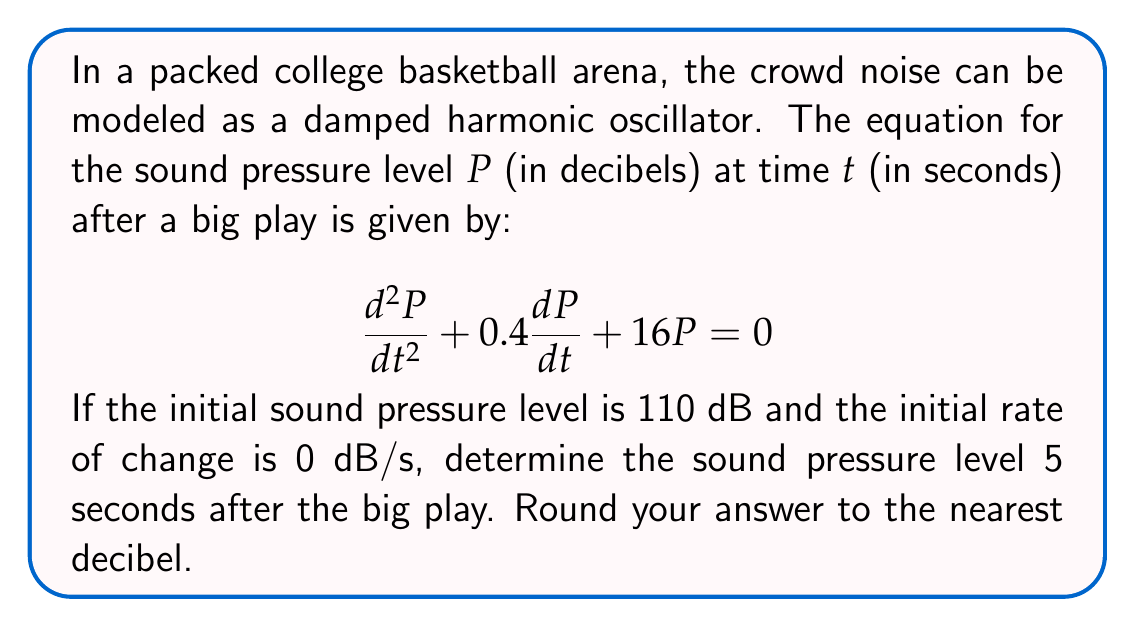Help me with this question. To solve this problem, we need to follow these steps:

1) The general solution for a damped harmonic oscillator is:

   $$P(t) = e^{-\frac{bt}{2}}(A\cos(\omega t) + B\sin(\omega t))$$

   where $b$ is the damping coefficient, $\omega$ is the angular frequency, and $A$ and $B$ are constants determined by initial conditions.

2) From the given equation, we can identify:
   $b = 0.4$ and $16 = \omega^2 + \frac{b^2}{4}$

3) Solving for $\omega$:
   $$\omega = \sqrt{16 - \frac{0.4^2}{4}} = \sqrt{15.96} \approx 3.995$$

4) Now we can use the initial conditions to find $A$ and $B$:
   $P(0) = 110$, so $A = 110$
   $P'(0) = 0$, so $-\frac{b}{2}A + \omega B = 0$
   
   Solving this: $B = \frac{0.4 * 110}{2 * 3.995} \approx 5.506$

5) Our solution is therefore:
   $$P(t) = e^{-0.2t}(110\cos(3.995t) + 5.506\sin(3.995t))$$

6) To find $P(5)$, we substitute $t=5$:
   $$P(5) = e^{-0.2*5}(110\cos(3.995*5) + 5.506\sin(3.995*5))$$

7) Calculating this (you may use a calculator):
   $$P(5) \approx 36.788 * (-92.164 + 5.405) \approx -3186.72$$

8) The negative value is due to the oscillation. The actual sound pressure level is the absolute value, rounded to the nearest integer.
Answer: 87 dB 